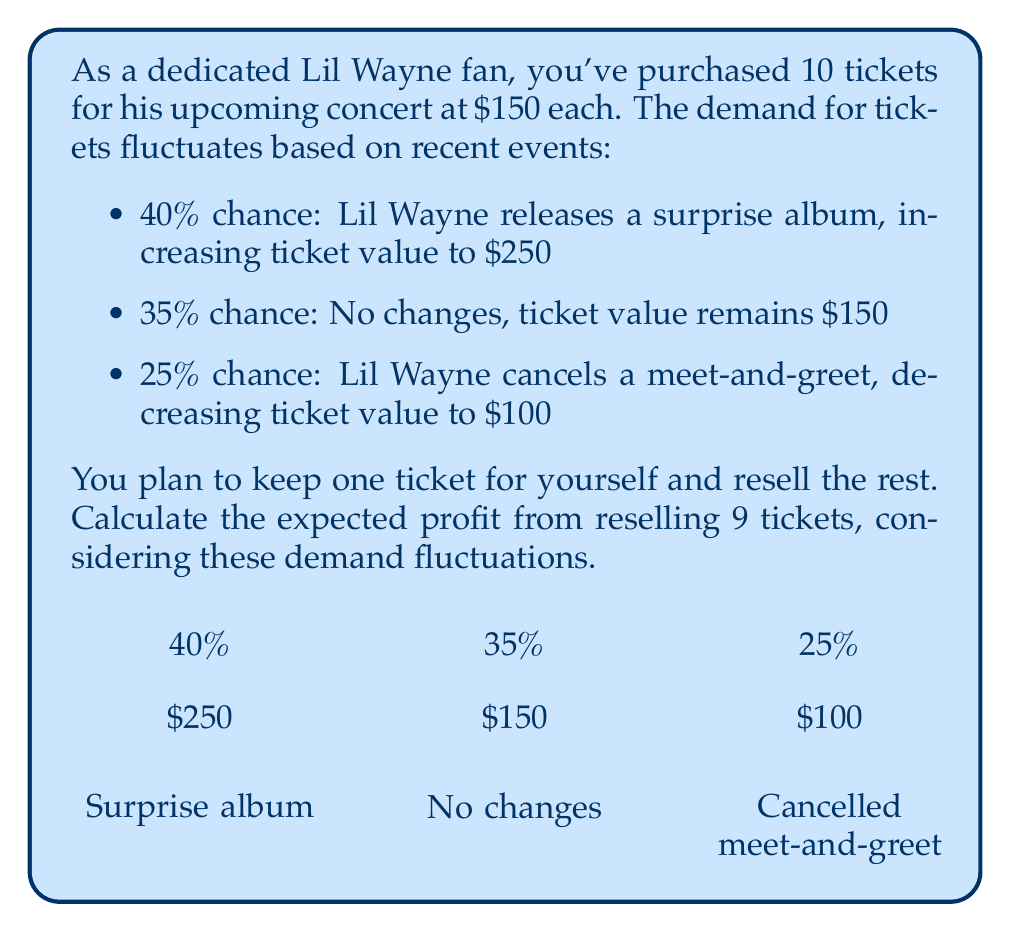Help me with this question. Let's approach this step-by-step:

1) First, calculate the total cost of the tickets:
   $10 \times \$150 = \$1500$

2) Now, let's calculate the expected value of a single ticket:
   $E(\text{ticket}) = 0.40 \times \$250 + 0.35 \times \$150 + 0.25 \times \$100$
   $E(\text{ticket}) = \$100 + \$52.50 + \$25 = \$177.50$

3) You're keeping one ticket, so we need to calculate the expected value for 9 tickets:
   $9 \times \$177.50 = \$1597.50$

4) To find the expected profit, subtract the total cost from the expected revenue:
   $\text{Expected Profit} = \$1597.50 - \$1500 = \$97.50$

Therefore, the expected profit from reselling 9 tickets, considering the demand fluctuations, is $\$97.50$.
Answer: $\$97.50$ 